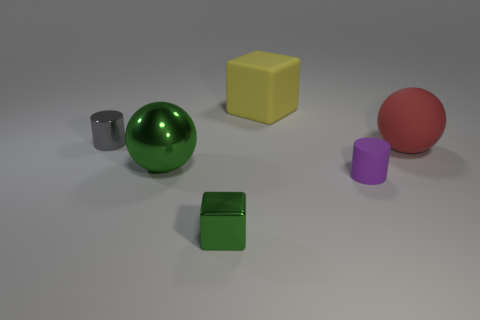Subtract all blue balls. Subtract all green blocks. How many balls are left? 2 Add 2 big cyan matte things. How many objects exist? 8 Subtract all cubes. How many objects are left? 4 Add 5 large green things. How many large green things exist? 6 Subtract 0 gray spheres. How many objects are left? 6 Subtract all big cyan rubber objects. Subtract all gray shiny cylinders. How many objects are left? 5 Add 4 small purple objects. How many small purple objects are left? 5 